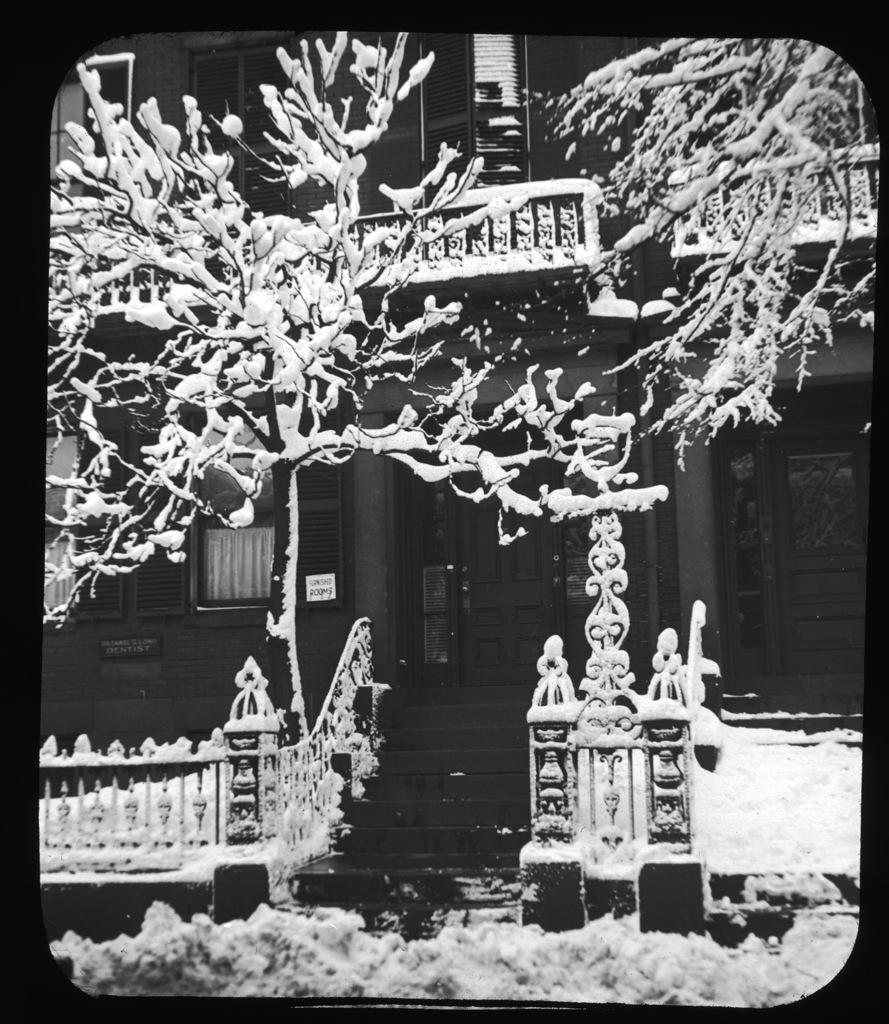What is the color scheme of the image? The image is black and white. What is the main subject in the center of the image? There is a building in the center of the image. What type of natural element can be seen in the image? There is a tree in the image. What architectural feature is present in the image? There are staircases in the image. What type of weather condition is depicted at the bottom of the image? There is snow at the bottom of the image. How many boats are visible in the image? There are no boats present in the image. What type of table is used for serving food in the image? There is no table visible in the image. 